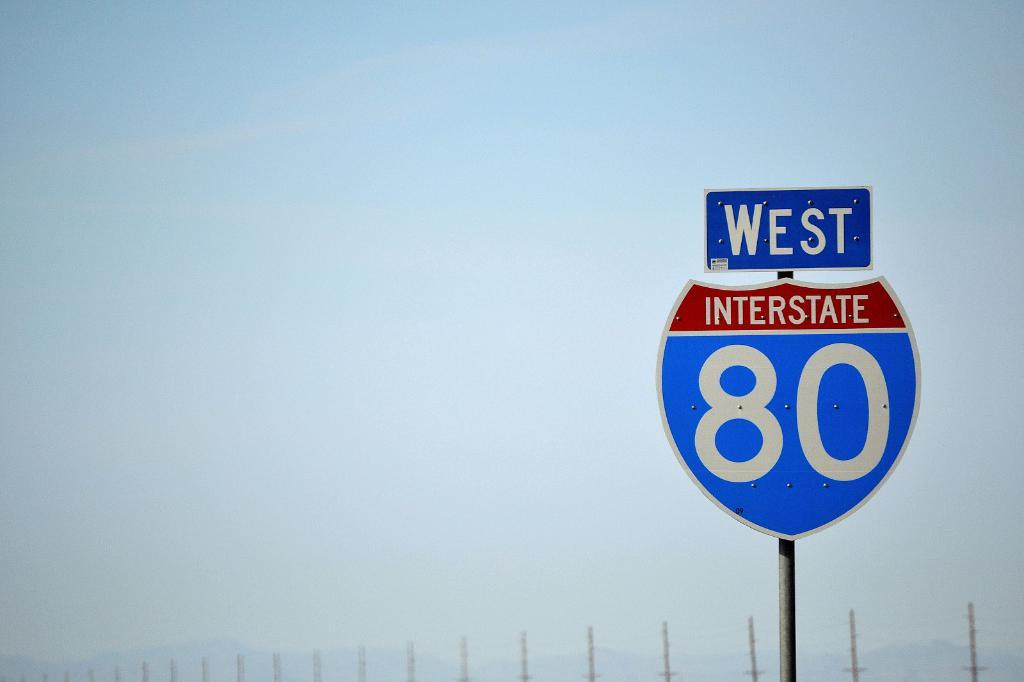<image>
Describe the image concisely. A blue and red sign for Interstate 80 can be sign on a cloudy day. 